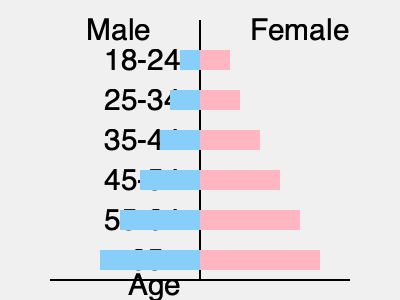The population pyramid above represents the age distribution of participants in meditation classes. Which age group shows the highest participation rate for both males and females, and what might this suggest about the potential benefits of meditation for reducing stress and aggression in society? To answer this question, we need to analyze the population pyramid and consider the implications of meditation on stress reduction and societal aggression:

1. Examine the pyramid:
   - The left side (blue) represents males, and the right side (pink) represents females.
   - The horizontal bars represent the number of participants in each age group.
   - Longer bars indicate higher participation rates.

2. Identify the age group with the highest participation:
   - The longest bars for both males and females are in the 65+ age group.
   - This indicates that the 65+ age group has the highest participation rate in meditation classes.

3. Consider the benefits of meditation for stress reduction:
   - Meditation is known to reduce stress, anxiety, and promote relaxation.
   - Older adults often face unique stressors such as health issues, retirement, and loss of loved ones.
   - High participation in the 65+ group suggests they may be seeking stress relief through meditation.

4. Reflect on the impact of meditation on aggression:
   - Meditation promotes mindfulness, emotional regulation, and empathy.
   - These qualities can lead to reduced aggression and improved social interactions.
   - The high participation of older adults may indicate a desire for inner peace and harmony.

5. Societal implications:
   - As older adults engage in meditation, they may become role models for younger generations.
   - This could lead to a ripple effect, promoting calmness and reducing overall societal aggression.
   - The wisdom and experience of older adults, combined with meditation practices, may contribute to a more peaceful society.

6. Potential for violence reduction:
   - While meditation alone may not solve all societal issues, it can be a valuable tool in promoting non-violent conflict resolution.
   - The high participation of older adults suggests a growing awareness of alternative methods to manage stress and emotions, which could indirectly contribute to reduced violence in society.
Answer: 65+ age group; suggests potential for stress reduction and decreased societal aggression through meditation. 